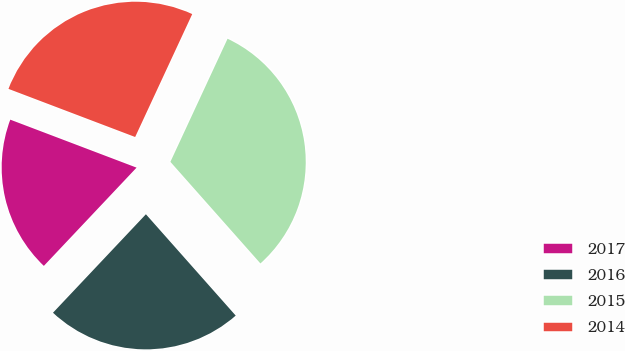Convert chart. <chart><loc_0><loc_0><loc_500><loc_500><pie_chart><fcel>2017<fcel>2016<fcel>2015<fcel>2014<nl><fcel>18.74%<fcel>23.58%<fcel>31.54%<fcel>26.14%<nl></chart> 